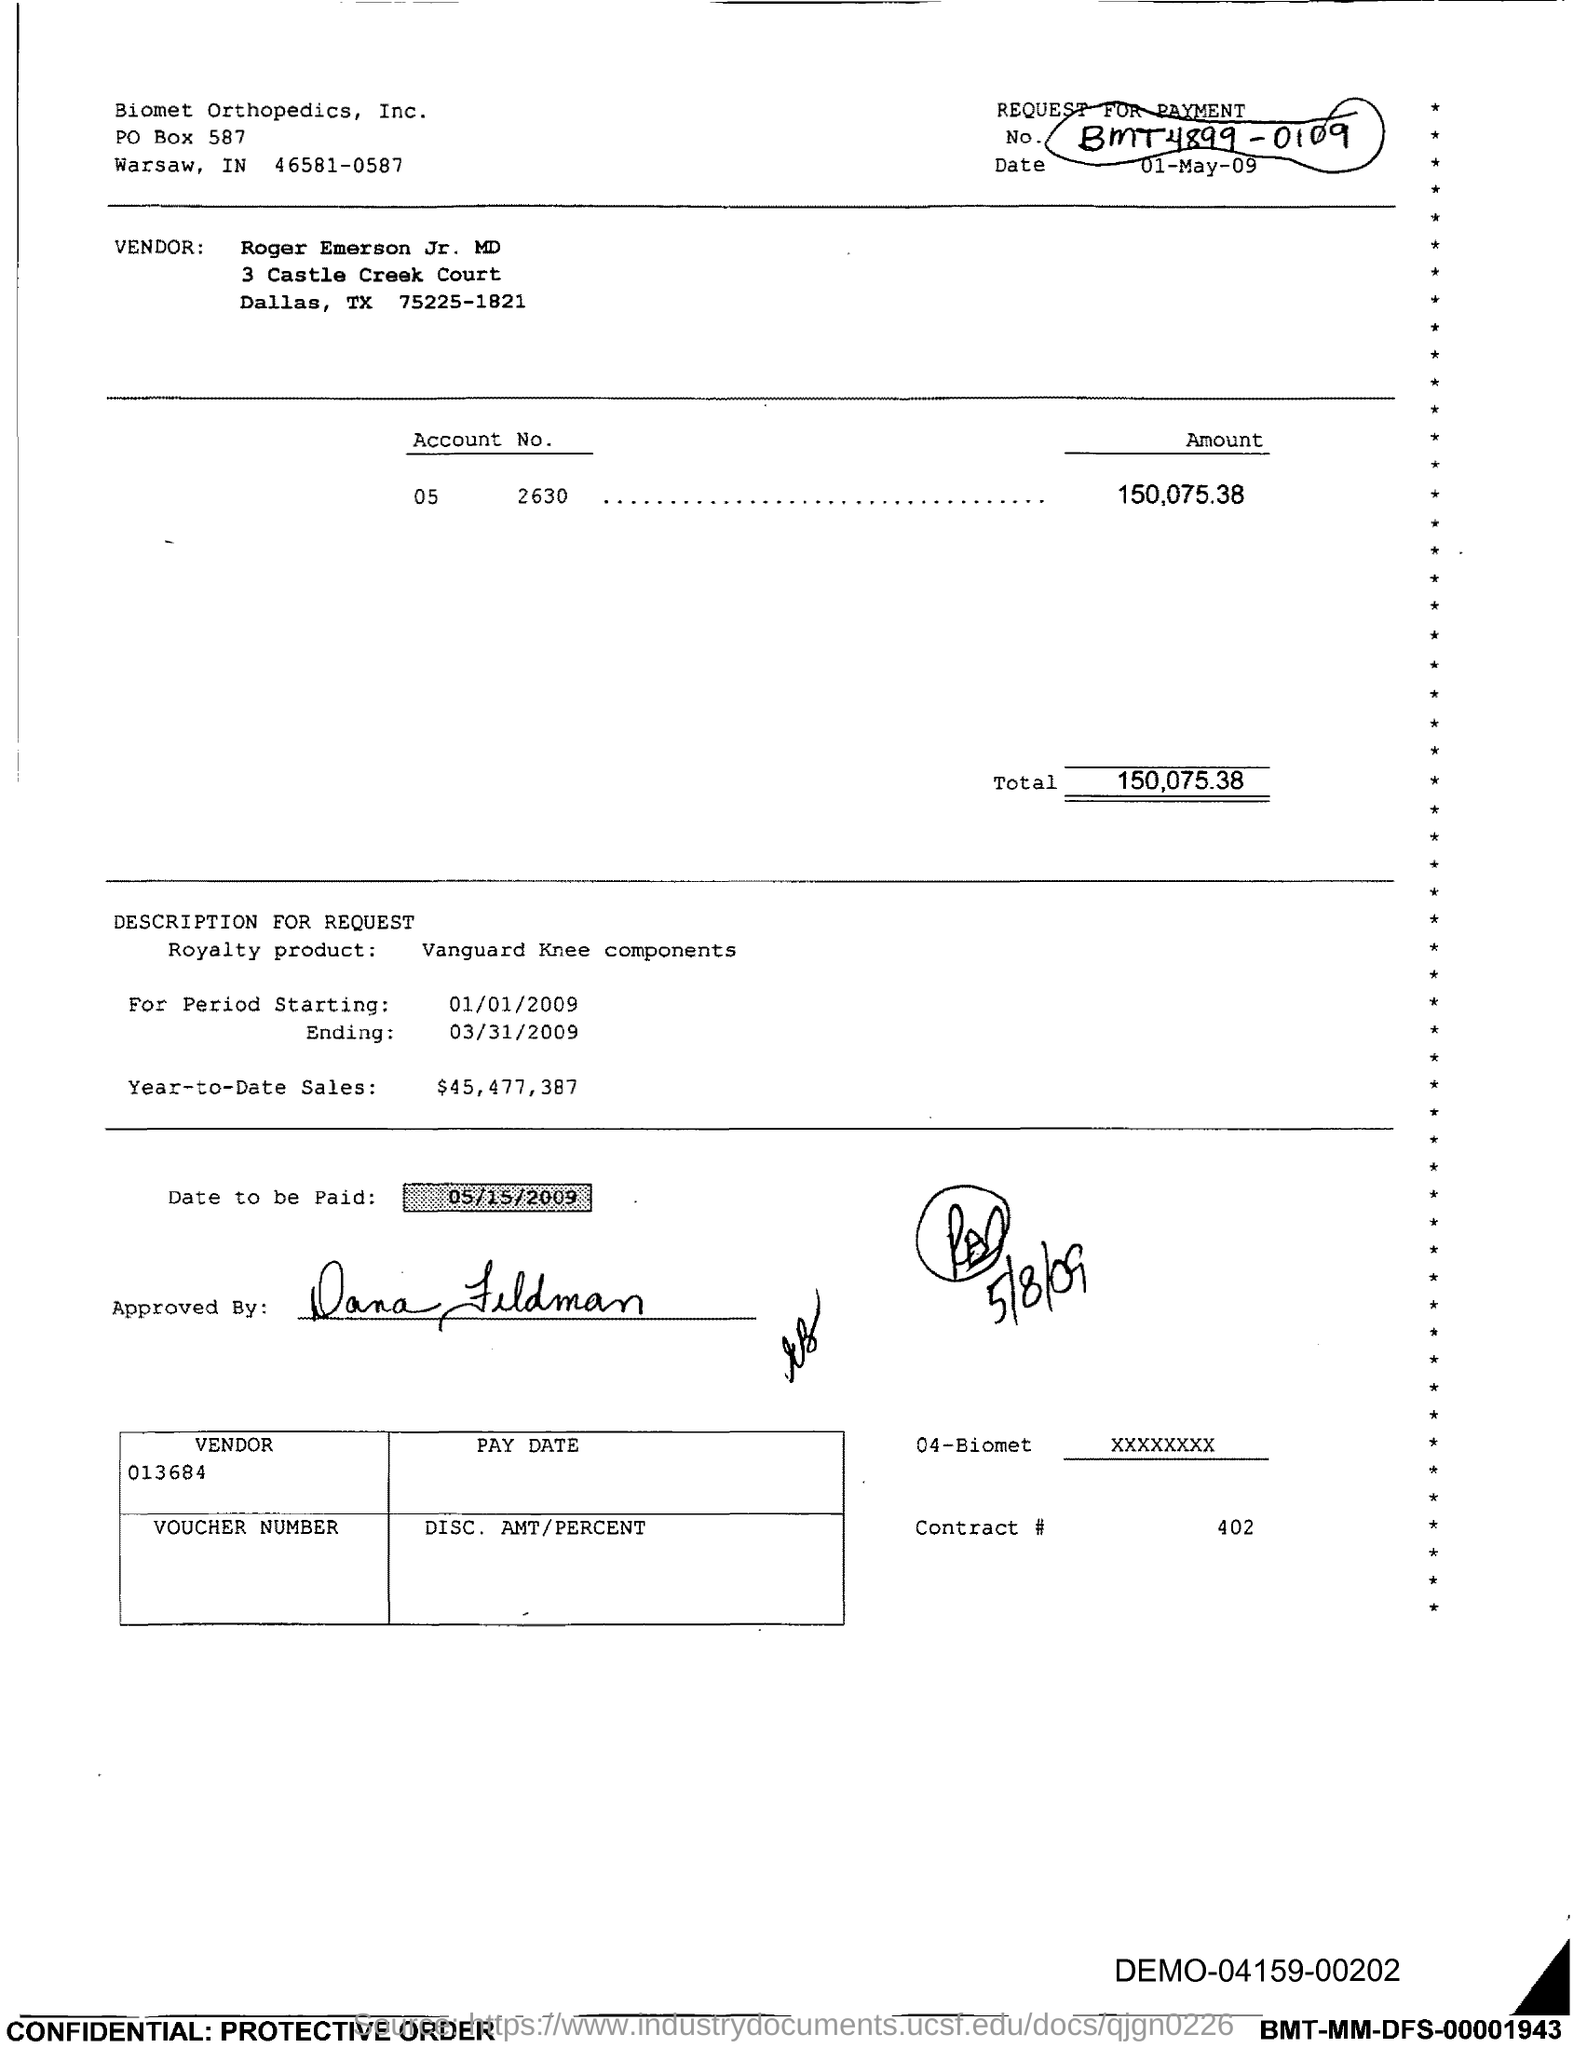Indicate a few pertinent items in this graphic. The total is 150,075.38... 